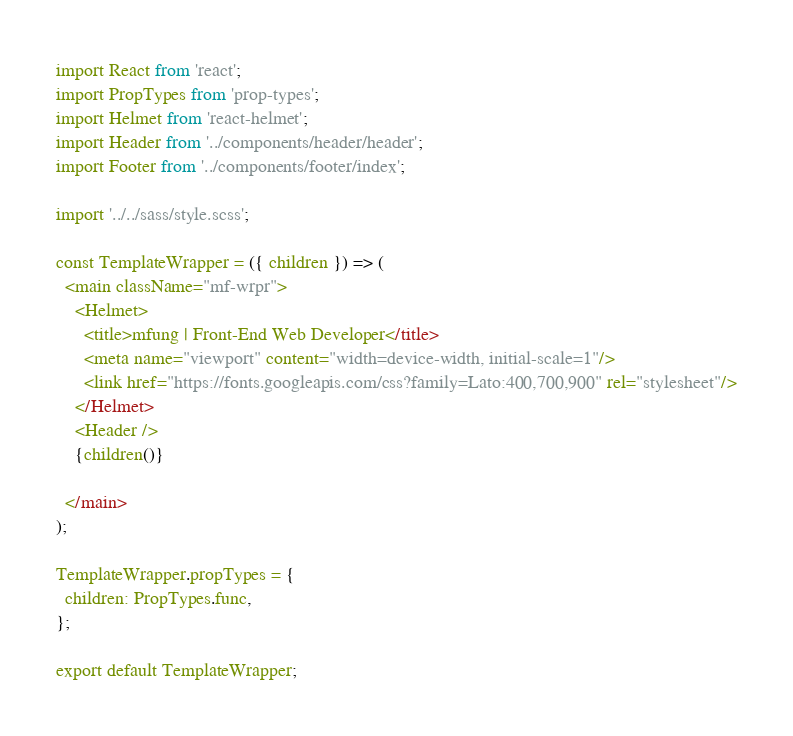Convert code to text. <code><loc_0><loc_0><loc_500><loc_500><_JavaScript_>import React from 'react';
import PropTypes from 'prop-types';
import Helmet from 'react-helmet';
import Header from '../components/header/header';
import Footer from '../components/footer/index';

import '../../sass/style.scss';

const TemplateWrapper = ({ children }) => (
  <main className="mf-wrpr">
    <Helmet>
      <title>mfung | Front-End Web Developer</title>
      <meta name="viewport" content="width=device-width, initial-scale=1"/>
      <link href="https://fonts.googleapis.com/css?family=Lato:400,700,900" rel="stylesheet"/>
    </Helmet>
    <Header />
    {children()}
    
  </main>
);

TemplateWrapper.propTypes = {
  children: PropTypes.func,
};

export default TemplateWrapper;
</code> 